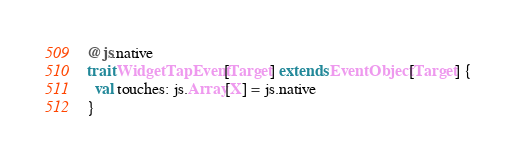<code> <loc_0><loc_0><loc_500><loc_500><_Scala_>@js.native
trait WidgetTapEvent[Target] extends EventObject[Target] {
  val touches: js.Array[X] = js.native
}

</code> 